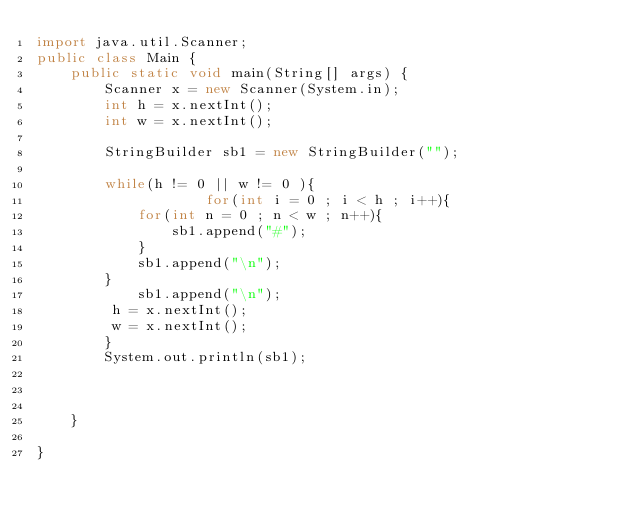<code> <loc_0><loc_0><loc_500><loc_500><_Java_>import java.util.Scanner;
public class Main {
	public static void main(String[] args) {
		Scanner x = new Scanner(System.in);
		int h = x.nextInt();
		int w = x.nextInt();
		
		StringBuilder sb1 = new StringBuilder("");
		
		while(h != 0 || w != 0 ){ 
					for(int i = 0 ; i < h ; i++){
			for(int n = 0 ; n < w ; n++){
				sb1.append("#");
			}
			sb1.append("\n");
		}
			sb1.append("\n");
		 h = x.nextInt();
		 w = x.nextInt();
		}
		System.out.println(sb1);
		
		
		
	}

}</code> 